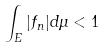Convert formula to latex. <formula><loc_0><loc_0><loc_500><loc_500>\int _ { E } | f _ { n } | d \mu < 1</formula> 